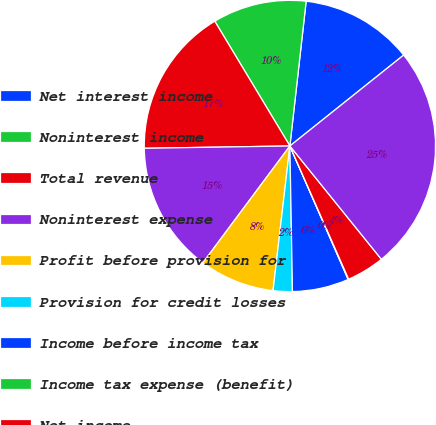Convert chart. <chart><loc_0><loc_0><loc_500><loc_500><pie_chart><fcel>Net interest income<fcel>Noninterest income<fcel>Total revenue<fcel>Noninterest expense<fcel>Profit before provision for<fcel>Provision for credit losses<fcel>Income before income tax<fcel>Income tax expense (benefit)<fcel>Net income<fcel>Loans and leases and loans<nl><fcel>12.49%<fcel>10.41%<fcel>16.63%<fcel>14.56%<fcel>8.34%<fcel>2.13%<fcel>6.27%<fcel>0.06%<fcel>4.2%<fcel>24.92%<nl></chart> 